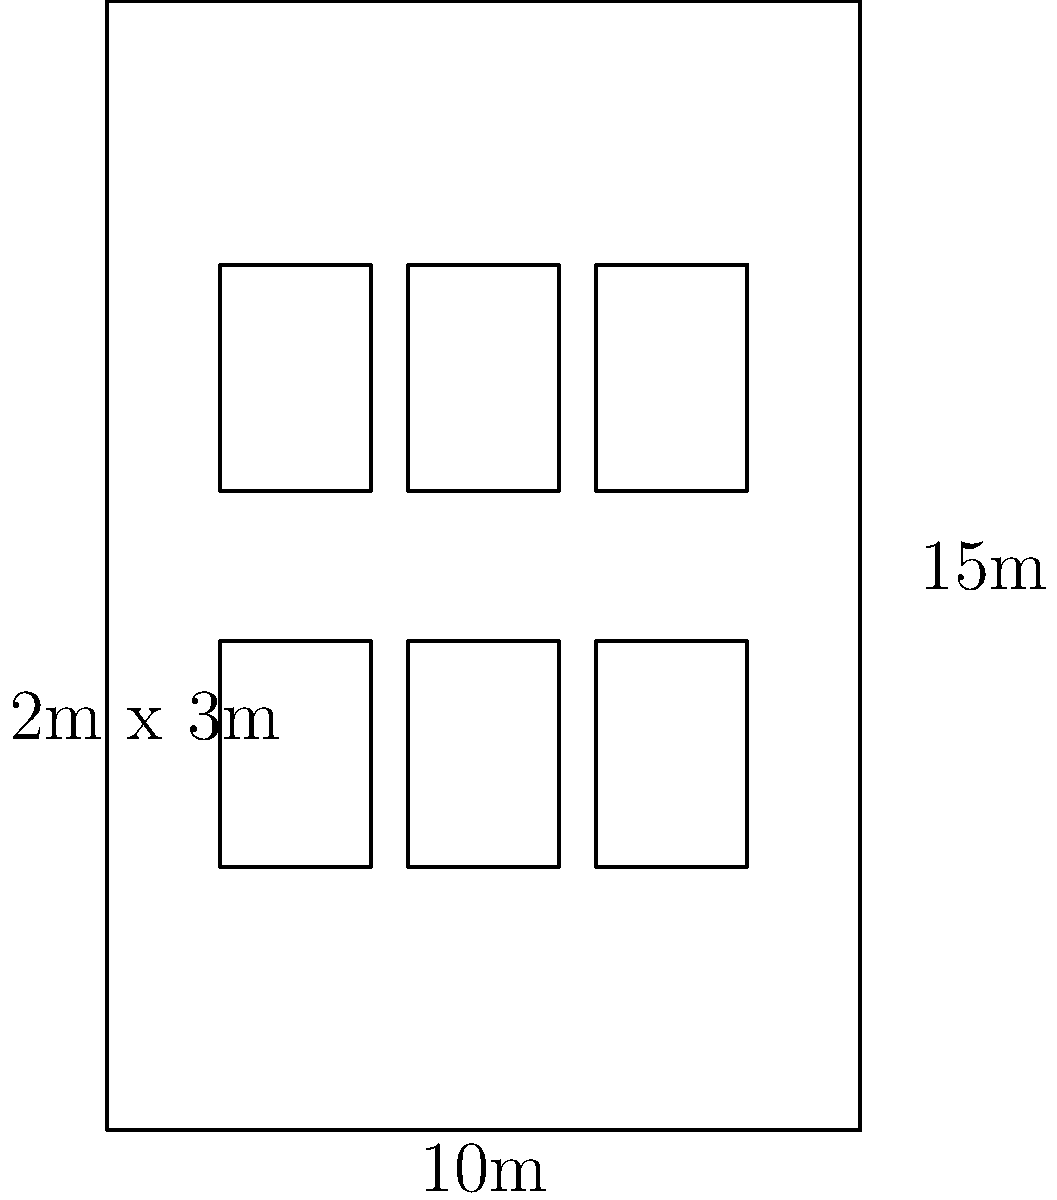A client wants to paint the facade of a rectangular building measuring 10m wide and 15m high. The building has 6 windows, each measuring 2m x 3m. Calculate the total surface area that needs to be painted, excluding the windows. How many liters of paint are needed if 1 liter covers 10 square meters? To solve this problem, we'll follow these steps:

1. Calculate the total surface area of the facade:
   $$A_{total} = \text{width} \times \text{height} = 10\text{m} \times 15\text{m} = 150\text{m}^2$$

2. Calculate the area of one window:
   $$A_{window} = \text{window width} \times \text{window height} = 2\text{m} \times 3\text{m} = 6\text{m}^2$$

3. Calculate the total area of all windows:
   $$A_{all windows} = \text{number of windows} \times A_{window} = 6 \times 6\text{m}^2 = 36\text{m}^2$$

4. Calculate the paintable area by subtracting the window area from the total area:
   $$A_{paintable} = A_{total} - A_{all windows} = 150\text{m}^2 - 36\text{m}^2 = 114\text{m}^2$$

5. Calculate the amount of paint needed:
   Given that 1 liter covers 10 square meters, we can set up the following equation:
   $$\text{Paint needed} = \frac{A_{paintable}}{10\text{m}^2/\text{L}} = \frac{114\text{m}^2}{10\text{m}^2/\text{L}} = 11.4\text{L}$$

Therefore, 11.4 liters of paint are needed to cover the paintable surface area of the building facade.
Answer: 11.4 liters 